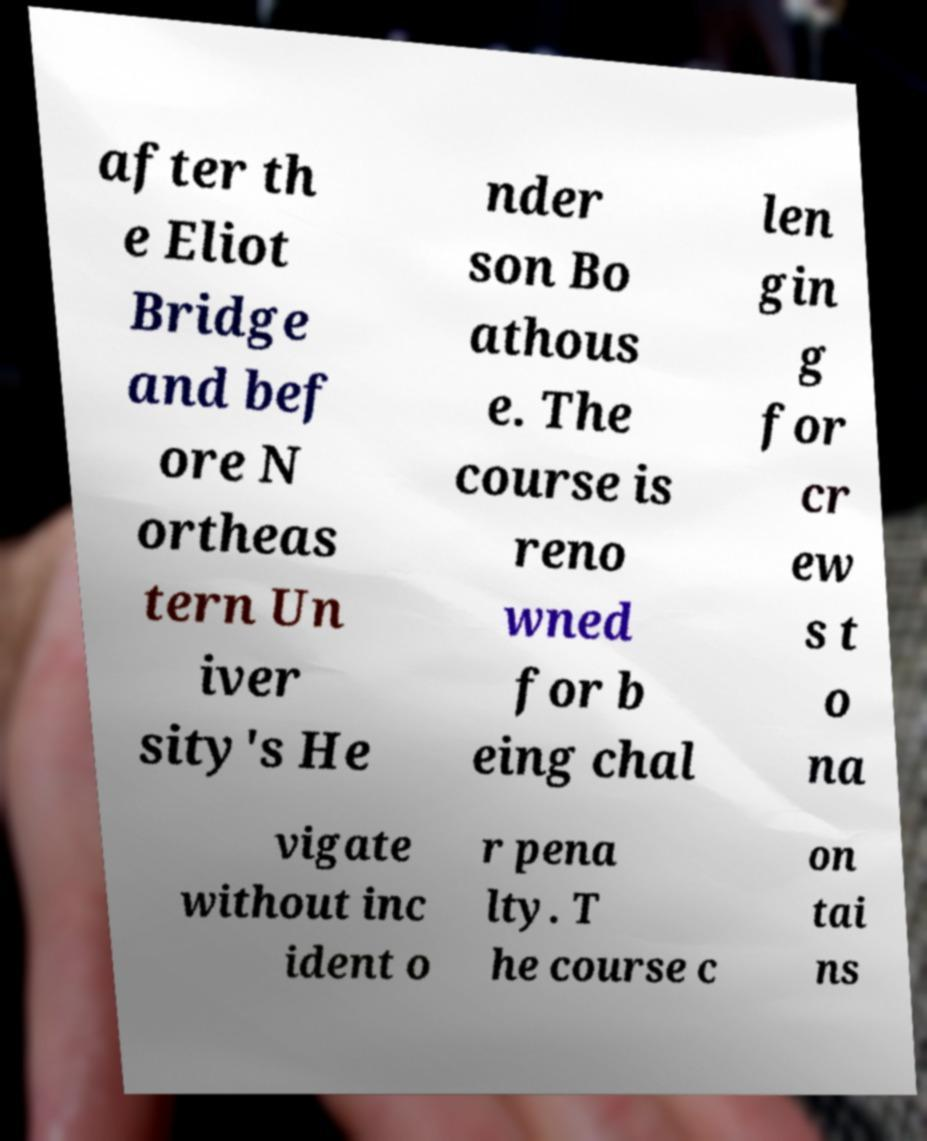Please identify and transcribe the text found in this image. after th e Eliot Bridge and bef ore N ortheas tern Un iver sity's He nder son Bo athous e. The course is reno wned for b eing chal len gin g for cr ew s t o na vigate without inc ident o r pena lty. T he course c on tai ns 